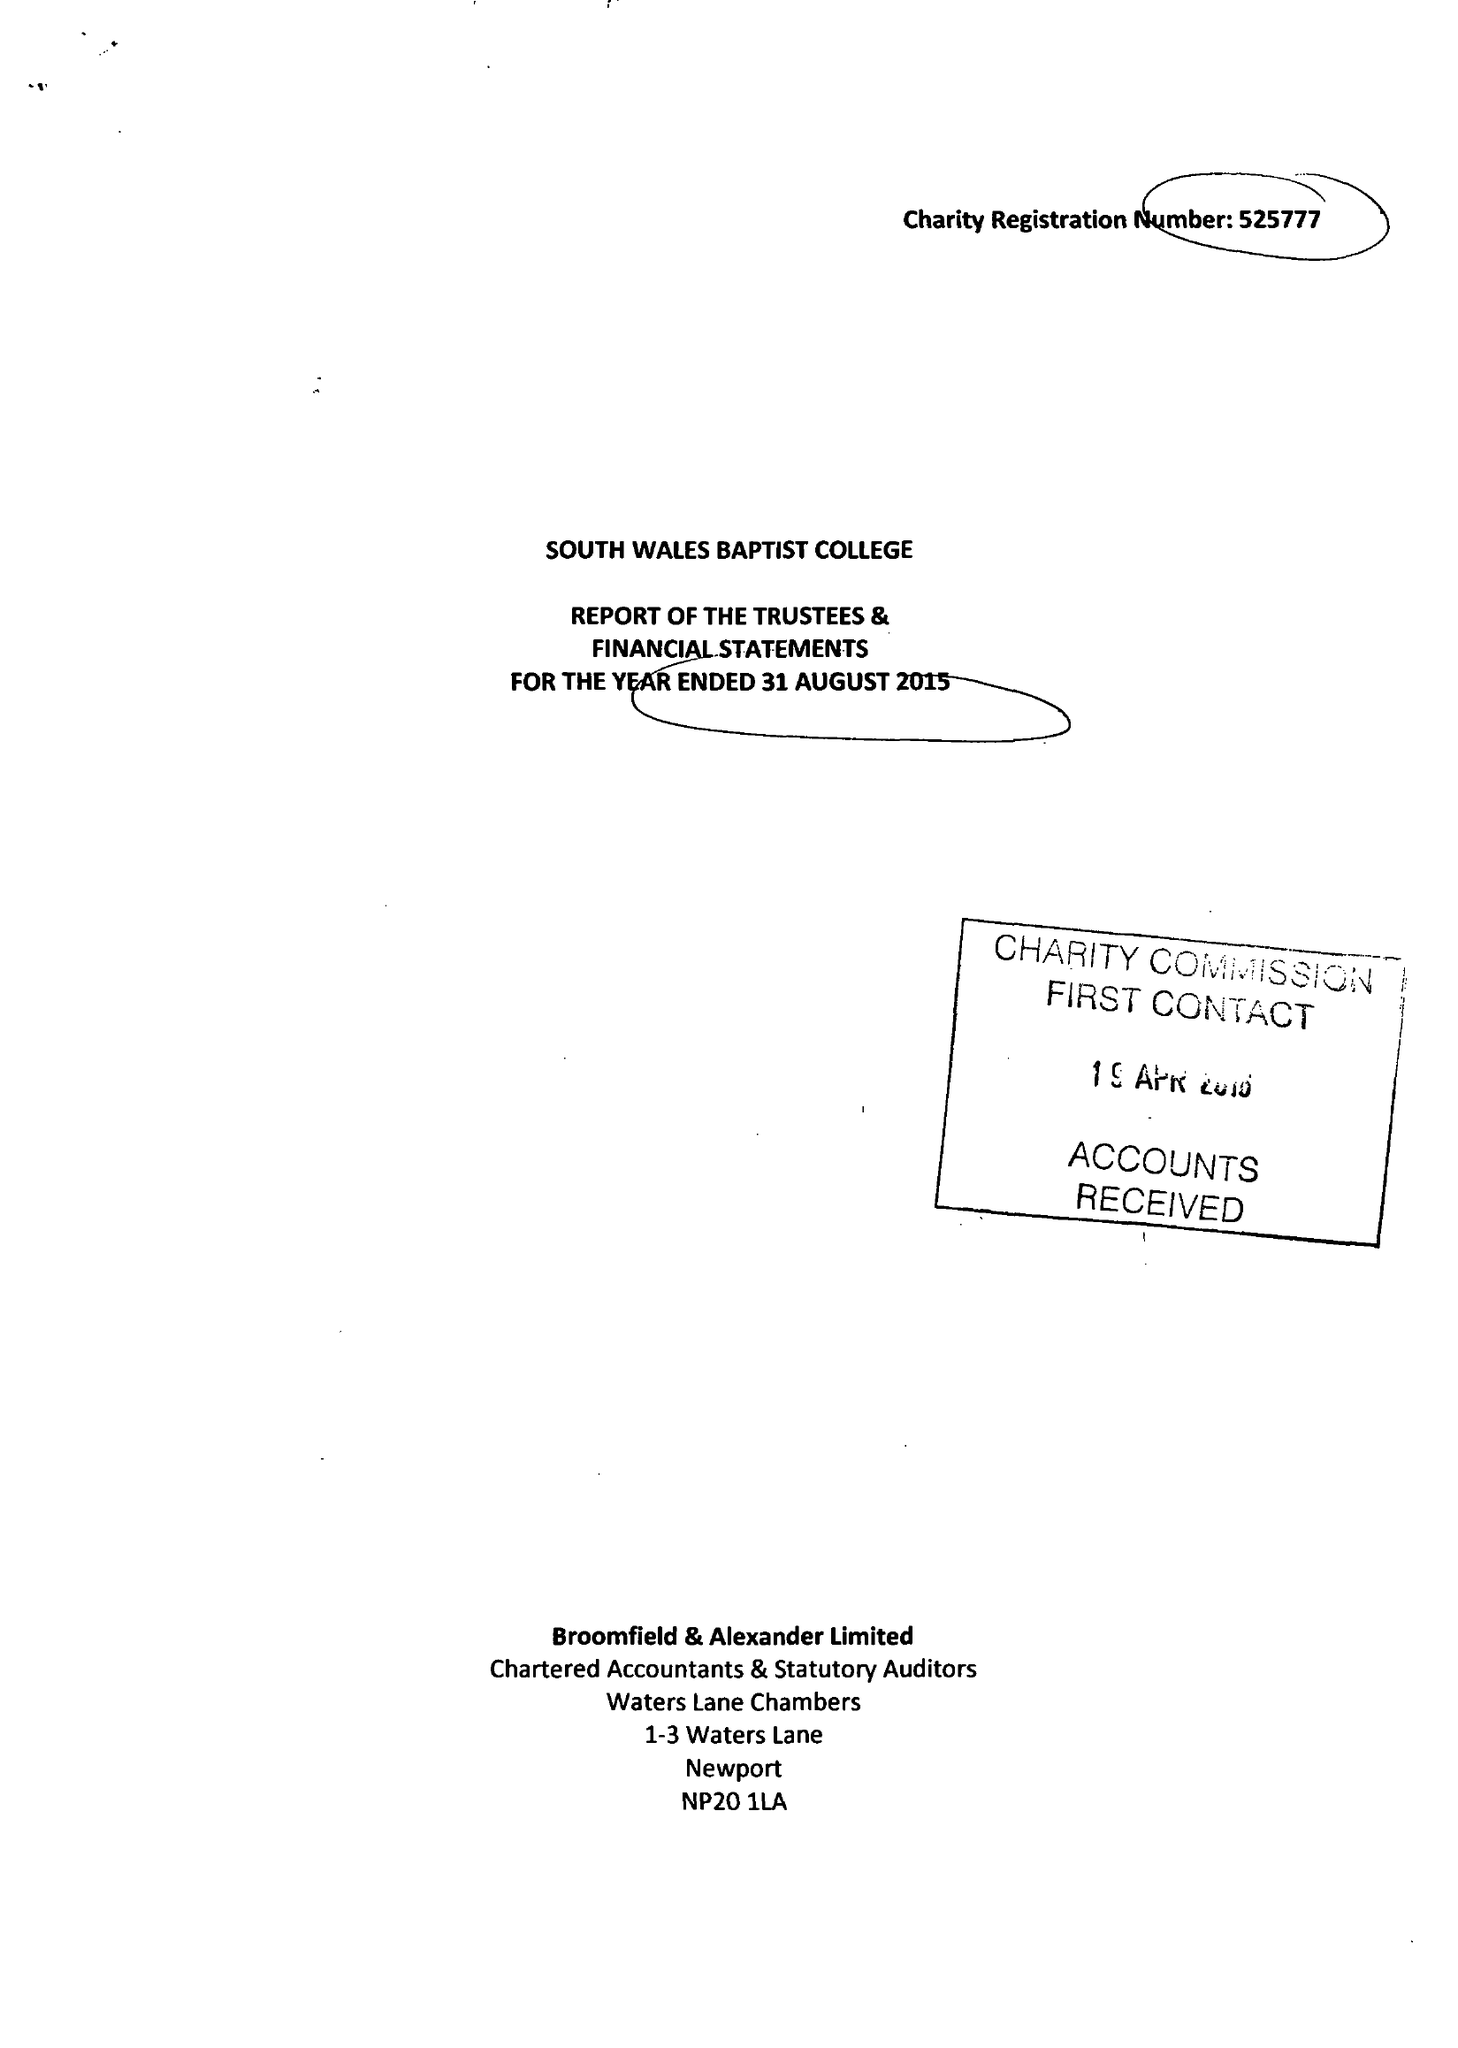What is the value for the income_annually_in_british_pounds?
Answer the question using a single word or phrase. 481318.00 